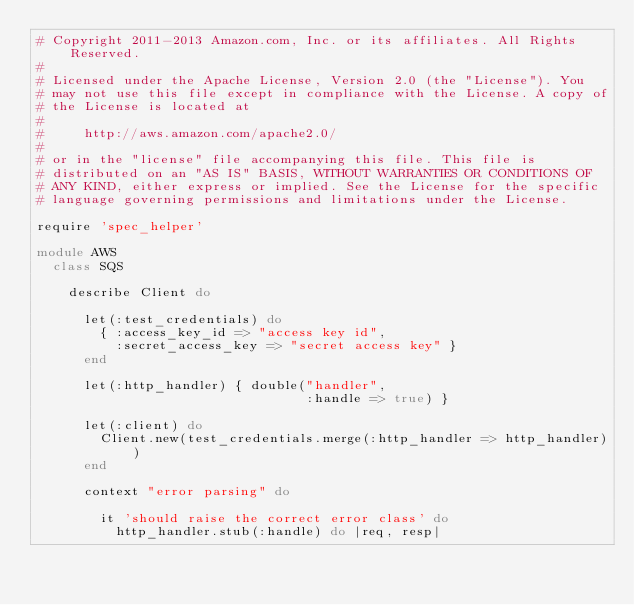<code> <loc_0><loc_0><loc_500><loc_500><_Ruby_># Copyright 2011-2013 Amazon.com, Inc. or its affiliates. All Rights Reserved.
#
# Licensed under the Apache License, Version 2.0 (the "License"). You
# may not use this file except in compliance with the License. A copy of
# the License is located at
#
#     http://aws.amazon.com/apache2.0/
#
# or in the "license" file accompanying this file. This file is
# distributed on an "AS IS" BASIS, WITHOUT WARRANTIES OR CONDITIONS OF
# ANY KIND, either express or implied. See the License for the specific
# language governing permissions and limitations under the License.

require 'spec_helper'

module AWS
  class SQS

    describe Client do

      let(:test_credentials) do
        { :access_key_id => "access key id",
          :secret_access_key => "secret access key" }
      end

      let(:http_handler) { double("handler",
                                  :handle => true) }

      let(:client) do
        Client.new(test_credentials.merge(:http_handler => http_handler))
      end

      context "error parsing" do

        it 'should raise the correct error class' do
          http_handler.stub(:handle) do |req, resp|</code> 